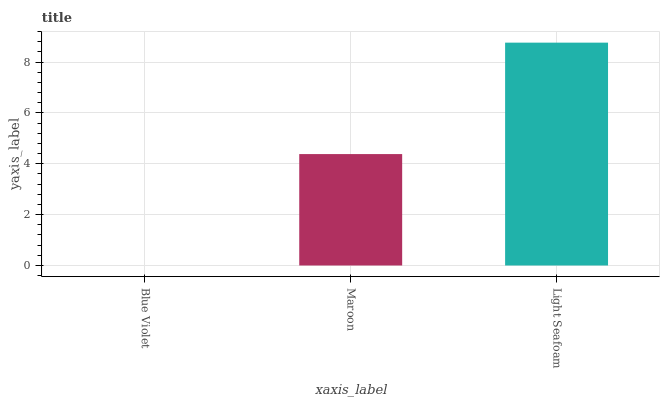Is Blue Violet the minimum?
Answer yes or no. Yes. Is Light Seafoam the maximum?
Answer yes or no. Yes. Is Maroon the minimum?
Answer yes or no. No. Is Maroon the maximum?
Answer yes or no. No. Is Maroon greater than Blue Violet?
Answer yes or no. Yes. Is Blue Violet less than Maroon?
Answer yes or no. Yes. Is Blue Violet greater than Maroon?
Answer yes or no. No. Is Maroon less than Blue Violet?
Answer yes or no. No. Is Maroon the high median?
Answer yes or no. Yes. Is Maroon the low median?
Answer yes or no. Yes. Is Blue Violet the high median?
Answer yes or no. No. Is Light Seafoam the low median?
Answer yes or no. No. 